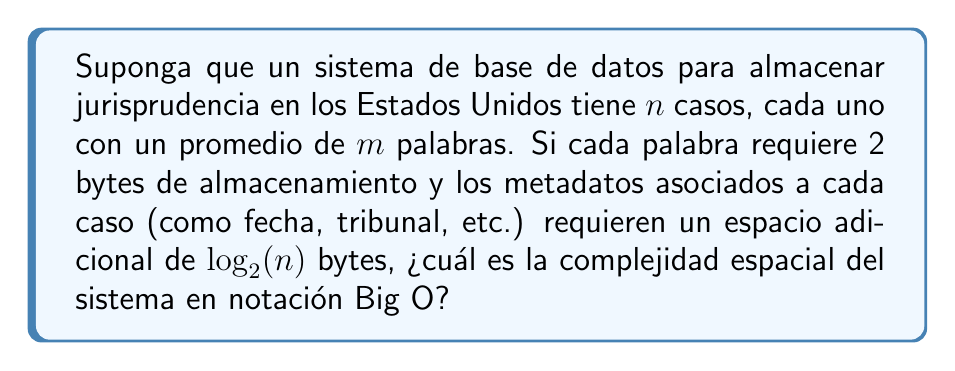Give your solution to this math problem. Para resolver este problema, seguiremos estos pasos:

1) Primero, calculemos el espacio requerido para almacenar el texto de todos los casos:
   - Cada caso tiene en promedio $m$ palabras
   - Cada palabra requiere 2 bytes
   - Hay $n$ casos en total
   - Espacio para el texto = $n \times m \times 2$ bytes

2) Ahora, calculemos el espacio requerido para los metadatos:
   - Cada caso requiere $\log_2(n)$ bytes adicionales para metadatos
   - Hay $n$ casos en total
   - Espacio para metadatos = $n \times \log_2(n)$ bytes

3) El espacio total es la suma de estos dos componentes:
   $$ \text{Espacio total} = (n \times m \times 2) + (n \times \log_2(n)) $$

4) Simplificando:
   $$ \text{Espacio total} = 2nm + n\log_2(n) $$

5) En notación Big O, nos interesa el término de crecimiento más rápido. Comparemos $2nm$ y $n\log_2(n)$:
   - $2nm$ crece linealmente con $n$ y $m$
   - $n\log_2(n)$ crece más lentamente que $n^2$ pero más rápidamente que $n$

6) Como $m$ es constante (promedio de palabras por caso), $2nm$ domina sobre $n\log_2(n)$ para valores grandes de $n$.

Por lo tanto, la complejidad espacial en notación Big O es $O(nm)$.
Answer: $O(nm)$ 